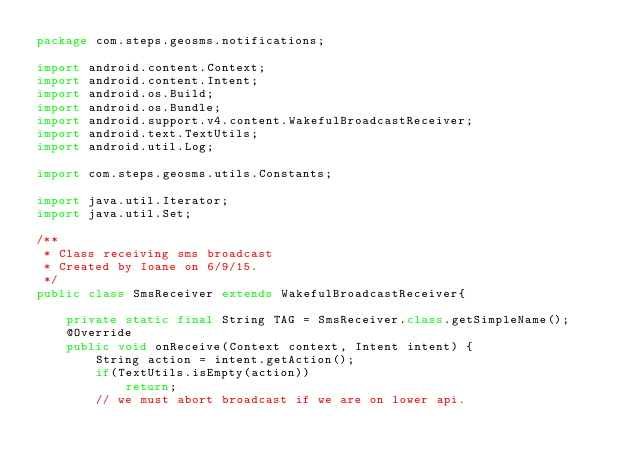Convert code to text. <code><loc_0><loc_0><loc_500><loc_500><_Java_>package com.steps.geosms.notifications;

import android.content.Context;
import android.content.Intent;
import android.os.Build;
import android.os.Bundle;
import android.support.v4.content.WakefulBroadcastReceiver;
import android.text.TextUtils;
import android.util.Log;

import com.steps.geosms.utils.Constants;

import java.util.Iterator;
import java.util.Set;

/**
 * Class receiving sms broadcast
 * Created by Ioane on 6/9/15.
 */
public class SmsReceiver extends WakefulBroadcastReceiver{

    private static final String TAG = SmsReceiver.class.getSimpleName();
    @Override
    public void onReceive(Context context, Intent intent) {
        String action = intent.getAction();
        if(TextUtils.isEmpty(action))
            return;
        // we must abort broadcast if we are on lower api.</code> 